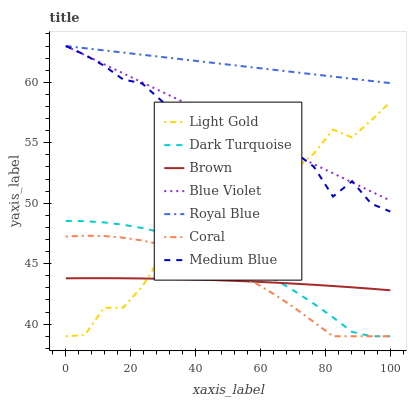Does Brown have the minimum area under the curve?
Answer yes or no. Yes. Does Royal Blue have the maximum area under the curve?
Answer yes or no. Yes. Does Dark Turquoise have the minimum area under the curve?
Answer yes or no. No. Does Dark Turquoise have the maximum area under the curve?
Answer yes or no. No. Is Blue Violet the smoothest?
Answer yes or no. Yes. Is Medium Blue the roughest?
Answer yes or no. Yes. Is Dark Turquoise the smoothest?
Answer yes or no. No. Is Dark Turquoise the roughest?
Answer yes or no. No. Does Dark Turquoise have the lowest value?
Answer yes or no. Yes. Does Medium Blue have the lowest value?
Answer yes or no. No. Does Blue Violet have the highest value?
Answer yes or no. Yes. Does Dark Turquoise have the highest value?
Answer yes or no. No. Is Brown less than Blue Violet?
Answer yes or no. Yes. Is Blue Violet greater than Brown?
Answer yes or no. Yes. Does Light Gold intersect Dark Turquoise?
Answer yes or no. Yes. Is Light Gold less than Dark Turquoise?
Answer yes or no. No. Is Light Gold greater than Dark Turquoise?
Answer yes or no. No. Does Brown intersect Blue Violet?
Answer yes or no. No. 